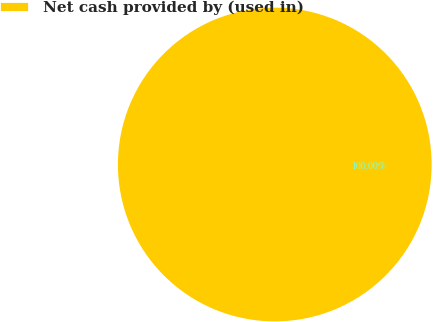Convert chart. <chart><loc_0><loc_0><loc_500><loc_500><pie_chart><fcel>Net cash provided by (used in)<nl><fcel>100.0%<nl></chart> 